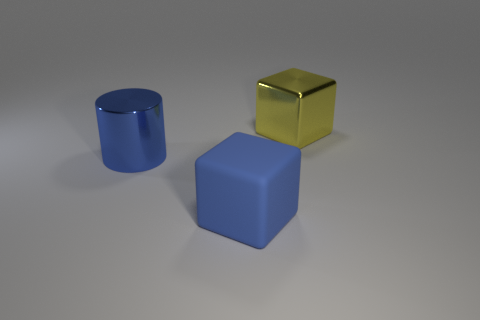What number of other things are the same size as the yellow thing?
Ensure brevity in your answer.  2. Are there any yellow shiny cubes in front of the yellow block that is behind the blue rubber thing that is in front of the large cylinder?
Your response must be concise. No. The matte block has what size?
Provide a short and direct response. Large. There is a blue matte cube in front of the large blue cylinder; what size is it?
Provide a succinct answer. Large. Do the blue rubber thing in front of the yellow metallic thing and the large yellow metallic object have the same size?
Provide a succinct answer. Yes. Are there any other things that are the same color as the metallic block?
Provide a short and direct response. No. The large blue matte thing has what shape?
Offer a very short reply. Cube. What number of big things are both behind the large rubber thing and on the right side of the big blue metallic thing?
Your answer should be very brief. 1. Do the big rubber block and the cylinder have the same color?
Make the answer very short. Yes. There is another object that is the same shape as the yellow object; what is its material?
Provide a short and direct response. Rubber. 